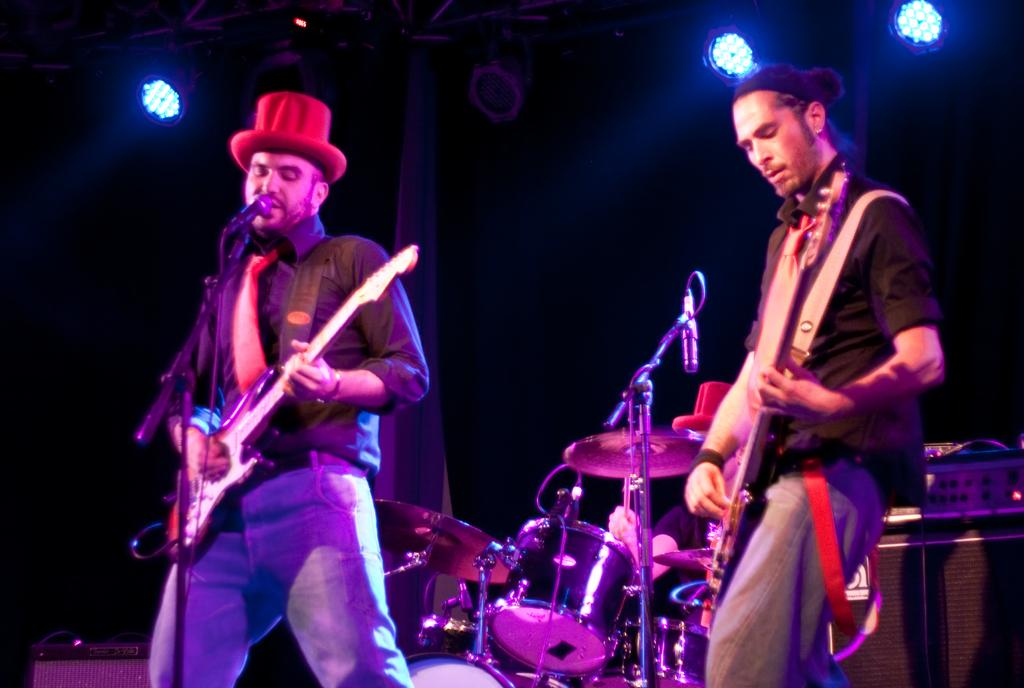How many people are in the image? There are two guys in the image. What are the guys doing in the image? The guys are playing guitars. What equipment is set up in front of the guys? There are microphones in front of the guys. What other musical instrument can be seen in the image? There are drums visible in the image. What type of lighting is present in the image? Colorful lights are present at the top of the image. What type of vessel is being used to hold the glue in the image? There is no vessel or glue present in the image; it features two guys playing guitars, microphones, drums, and colorful lights. 